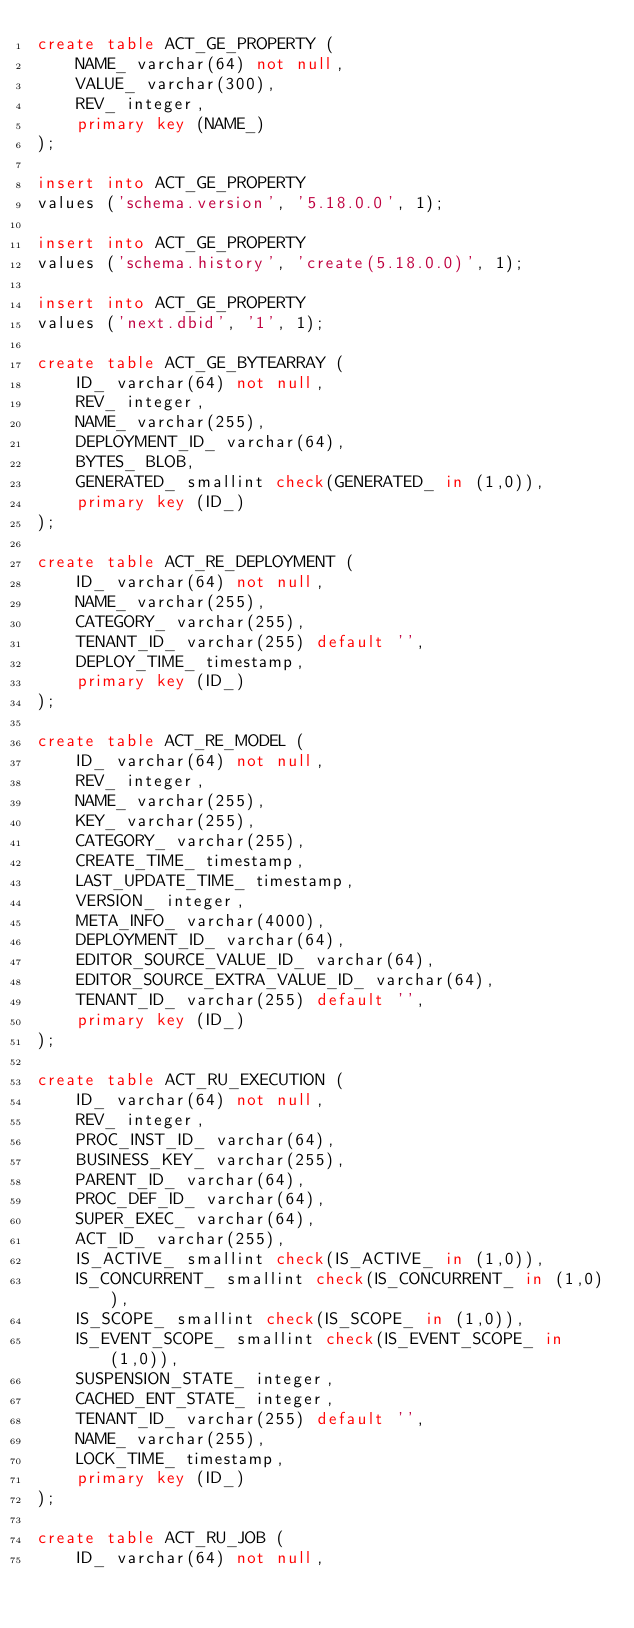Convert code to text. <code><loc_0><loc_0><loc_500><loc_500><_SQL_>create table ACT_GE_PROPERTY (
    NAME_ varchar(64) not null,
    VALUE_ varchar(300),
    REV_ integer,
    primary key (NAME_)
);

insert into ACT_GE_PROPERTY
values ('schema.version', '5.18.0.0', 1);

insert into ACT_GE_PROPERTY
values ('schema.history', 'create(5.18.0.0)', 1);

insert into ACT_GE_PROPERTY
values ('next.dbid', '1', 1);

create table ACT_GE_BYTEARRAY (
    ID_ varchar(64) not null,
    REV_ integer,
    NAME_ varchar(255),
    DEPLOYMENT_ID_ varchar(64),
    BYTES_ BLOB,
    GENERATED_ smallint check(GENERATED_ in (1,0)),
    primary key (ID_)
);

create table ACT_RE_DEPLOYMENT (
    ID_ varchar(64) not null,
    NAME_ varchar(255),
    CATEGORY_ varchar(255),
    TENANT_ID_ varchar(255) default '',
    DEPLOY_TIME_ timestamp,
    primary key (ID_)
);

create table ACT_RE_MODEL (
    ID_ varchar(64) not null,
    REV_ integer,
    NAME_ varchar(255),
    KEY_ varchar(255),
    CATEGORY_ varchar(255),
    CREATE_TIME_ timestamp,
    LAST_UPDATE_TIME_ timestamp,
    VERSION_ integer,
    META_INFO_ varchar(4000),
    DEPLOYMENT_ID_ varchar(64),
    EDITOR_SOURCE_VALUE_ID_ varchar(64),
    EDITOR_SOURCE_EXTRA_VALUE_ID_ varchar(64),
    TENANT_ID_ varchar(255) default '',
    primary key (ID_)
);

create table ACT_RU_EXECUTION (
    ID_ varchar(64) not null,
    REV_ integer,
    PROC_INST_ID_ varchar(64),
    BUSINESS_KEY_ varchar(255),
    PARENT_ID_ varchar(64),
    PROC_DEF_ID_ varchar(64),
    SUPER_EXEC_ varchar(64),
    ACT_ID_ varchar(255),
    IS_ACTIVE_ smallint check(IS_ACTIVE_ in (1,0)),
    IS_CONCURRENT_ smallint check(IS_CONCURRENT_ in (1,0)),
    IS_SCOPE_ smallint check(IS_SCOPE_ in (1,0)),
    IS_EVENT_SCOPE_ smallint check(IS_EVENT_SCOPE_ in (1,0)),
	SUSPENSION_STATE_ integer,
	CACHED_ENT_STATE_ integer,
	TENANT_ID_ varchar(255) default '',
	NAME_ varchar(255),
	LOCK_TIME_ timestamp,
    primary key (ID_)
);

create table ACT_RU_JOB (
    ID_ varchar(64) not null,</code> 